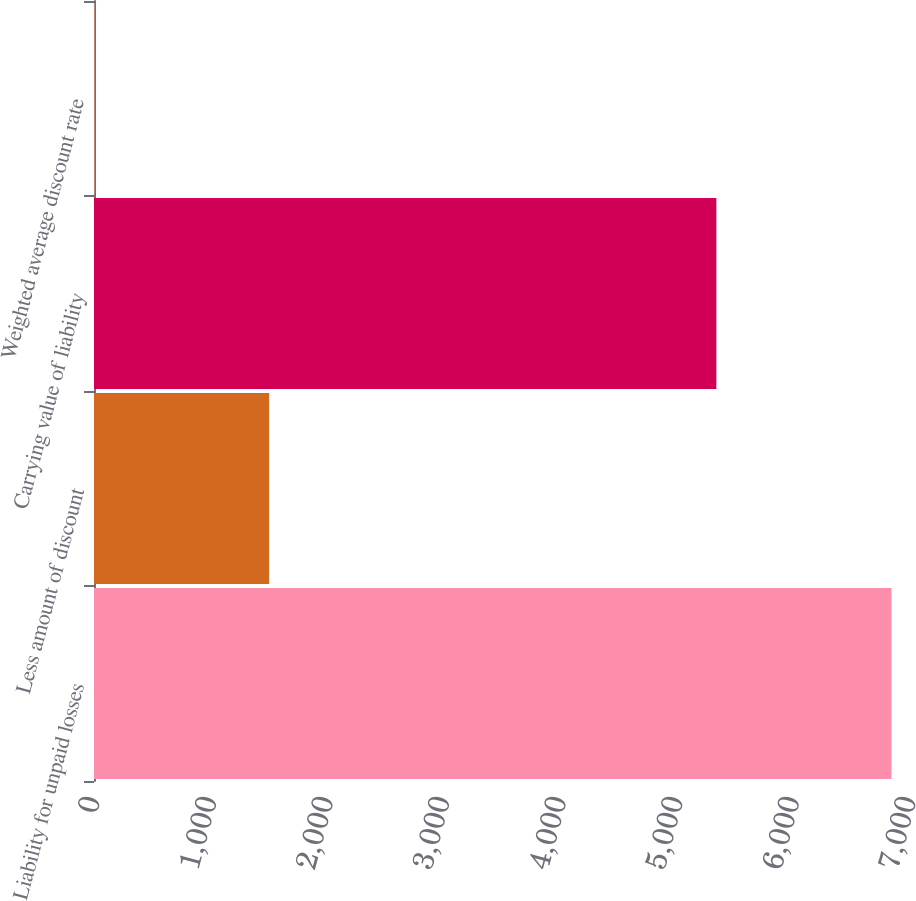<chart> <loc_0><loc_0><loc_500><loc_500><bar_chart><fcel>Liability for unpaid losses<fcel>Less amount of discount<fcel>Carrying value of liability<fcel>Weighted average discount rate<nl><fcel>6841<fcel>1502<fcel>5339<fcel>4.5<nl></chart> 